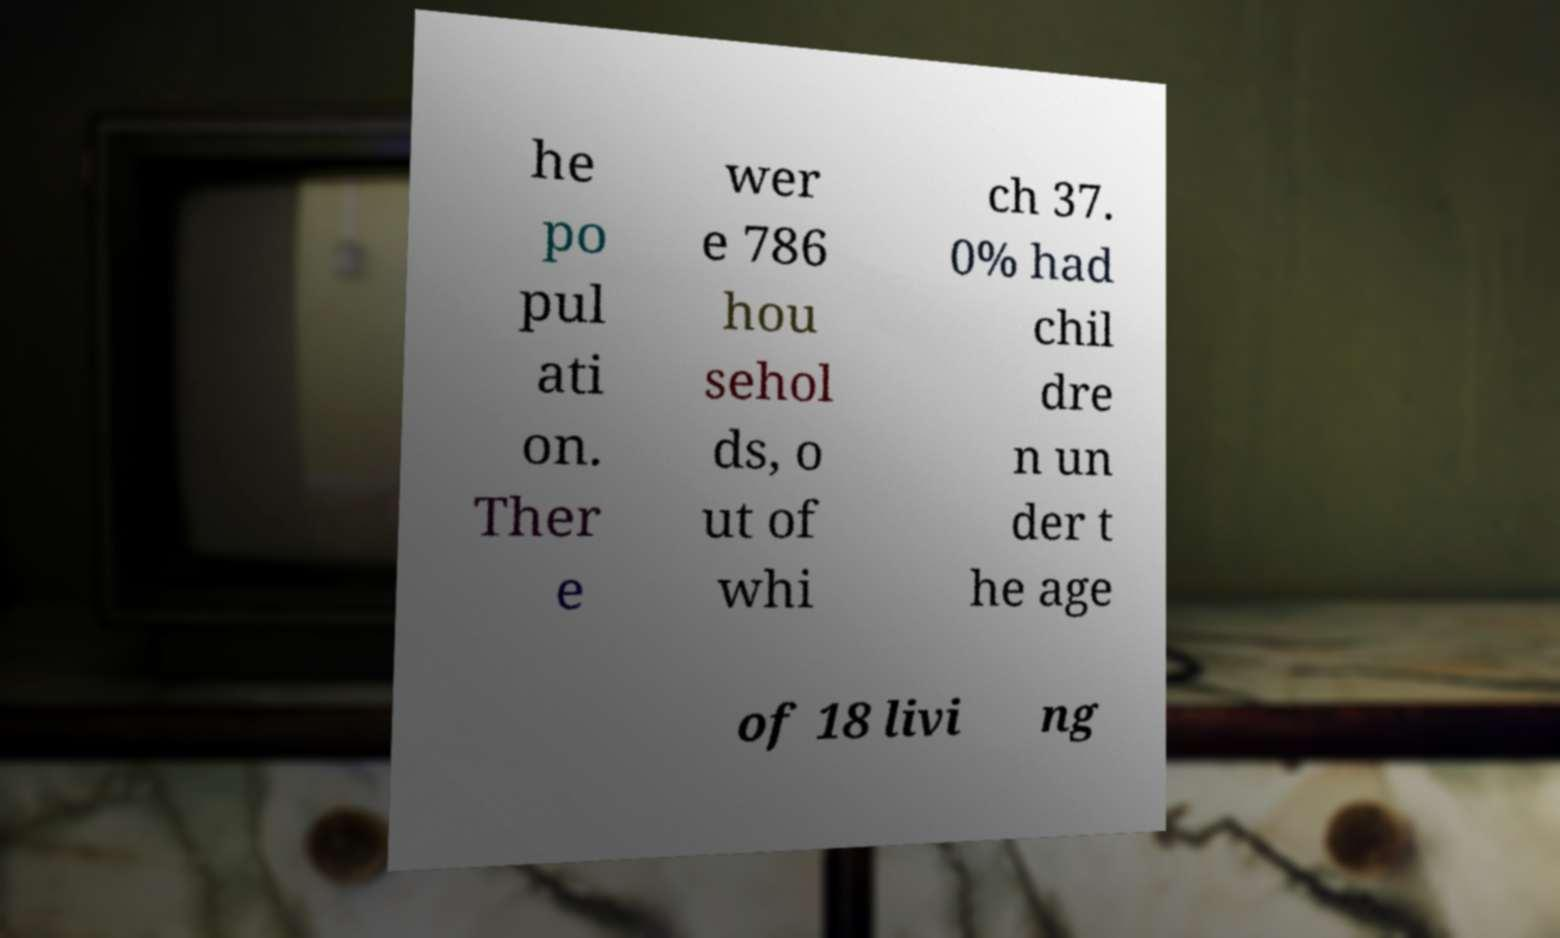Can you accurately transcribe the text from the provided image for me? he po pul ati on. Ther e wer e 786 hou sehol ds, o ut of whi ch 37. 0% had chil dre n un der t he age of 18 livi ng 